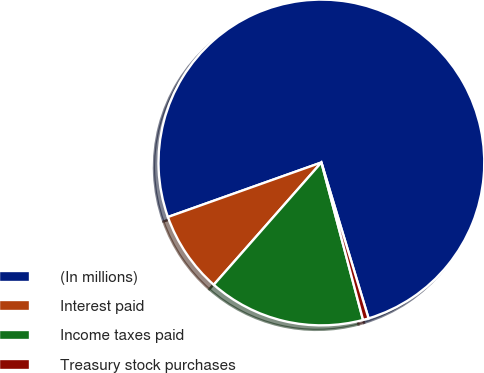Convert chart. <chart><loc_0><loc_0><loc_500><loc_500><pie_chart><fcel>(In millions)<fcel>Interest paid<fcel>Income taxes paid<fcel>Treasury stock purchases<nl><fcel>75.75%<fcel>8.08%<fcel>15.6%<fcel>0.56%<nl></chart> 